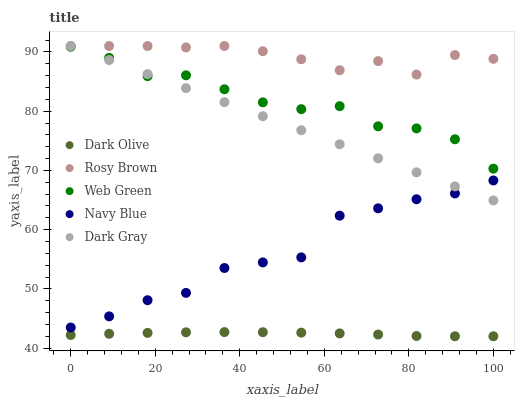Does Dark Olive have the minimum area under the curve?
Answer yes or no. Yes. Does Rosy Brown have the maximum area under the curve?
Answer yes or no. Yes. Does Navy Blue have the minimum area under the curve?
Answer yes or no. No. Does Navy Blue have the maximum area under the curve?
Answer yes or no. No. Is Dark Gray the smoothest?
Answer yes or no. Yes. Is Navy Blue the roughest?
Answer yes or no. Yes. Is Rosy Brown the smoothest?
Answer yes or no. No. Is Rosy Brown the roughest?
Answer yes or no. No. Does Dark Olive have the lowest value?
Answer yes or no. Yes. Does Navy Blue have the lowest value?
Answer yes or no. No. Does Rosy Brown have the highest value?
Answer yes or no. Yes. Does Navy Blue have the highest value?
Answer yes or no. No. Is Dark Olive less than Rosy Brown?
Answer yes or no. Yes. Is Dark Gray greater than Dark Olive?
Answer yes or no. Yes. Does Dark Gray intersect Web Green?
Answer yes or no. Yes. Is Dark Gray less than Web Green?
Answer yes or no. No. Is Dark Gray greater than Web Green?
Answer yes or no. No. Does Dark Olive intersect Rosy Brown?
Answer yes or no. No. 